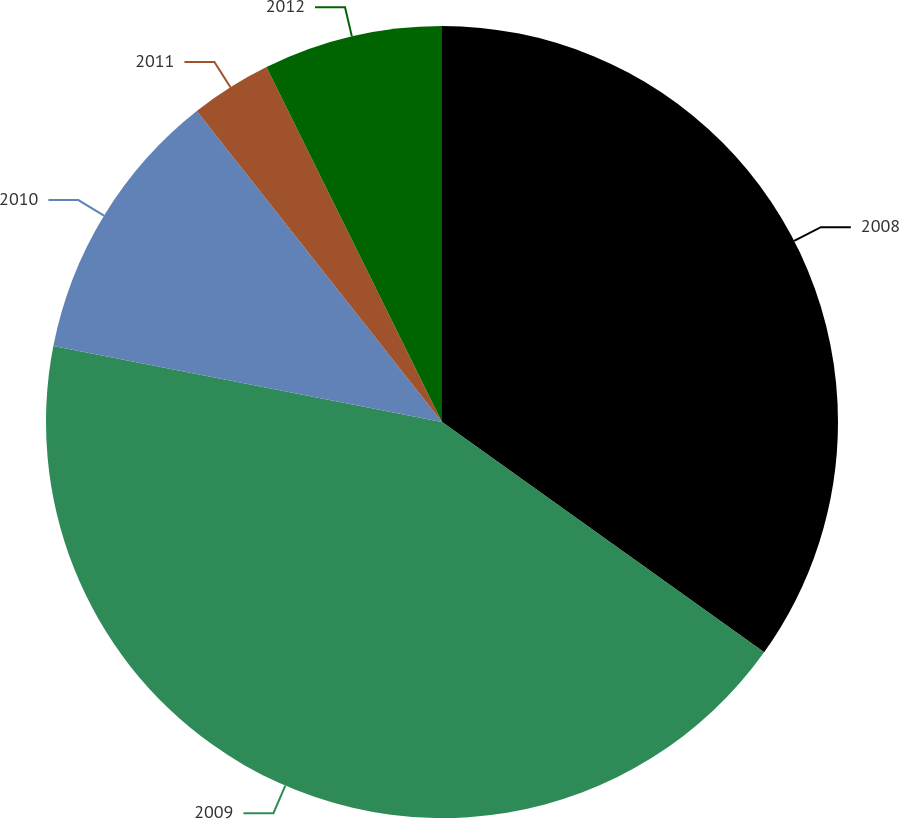Convert chart to OTSL. <chart><loc_0><loc_0><loc_500><loc_500><pie_chart><fcel>2008<fcel>2009<fcel>2010<fcel>2011<fcel>2012<nl><fcel>34.88%<fcel>43.19%<fcel>11.3%<fcel>3.32%<fcel>7.31%<nl></chart> 